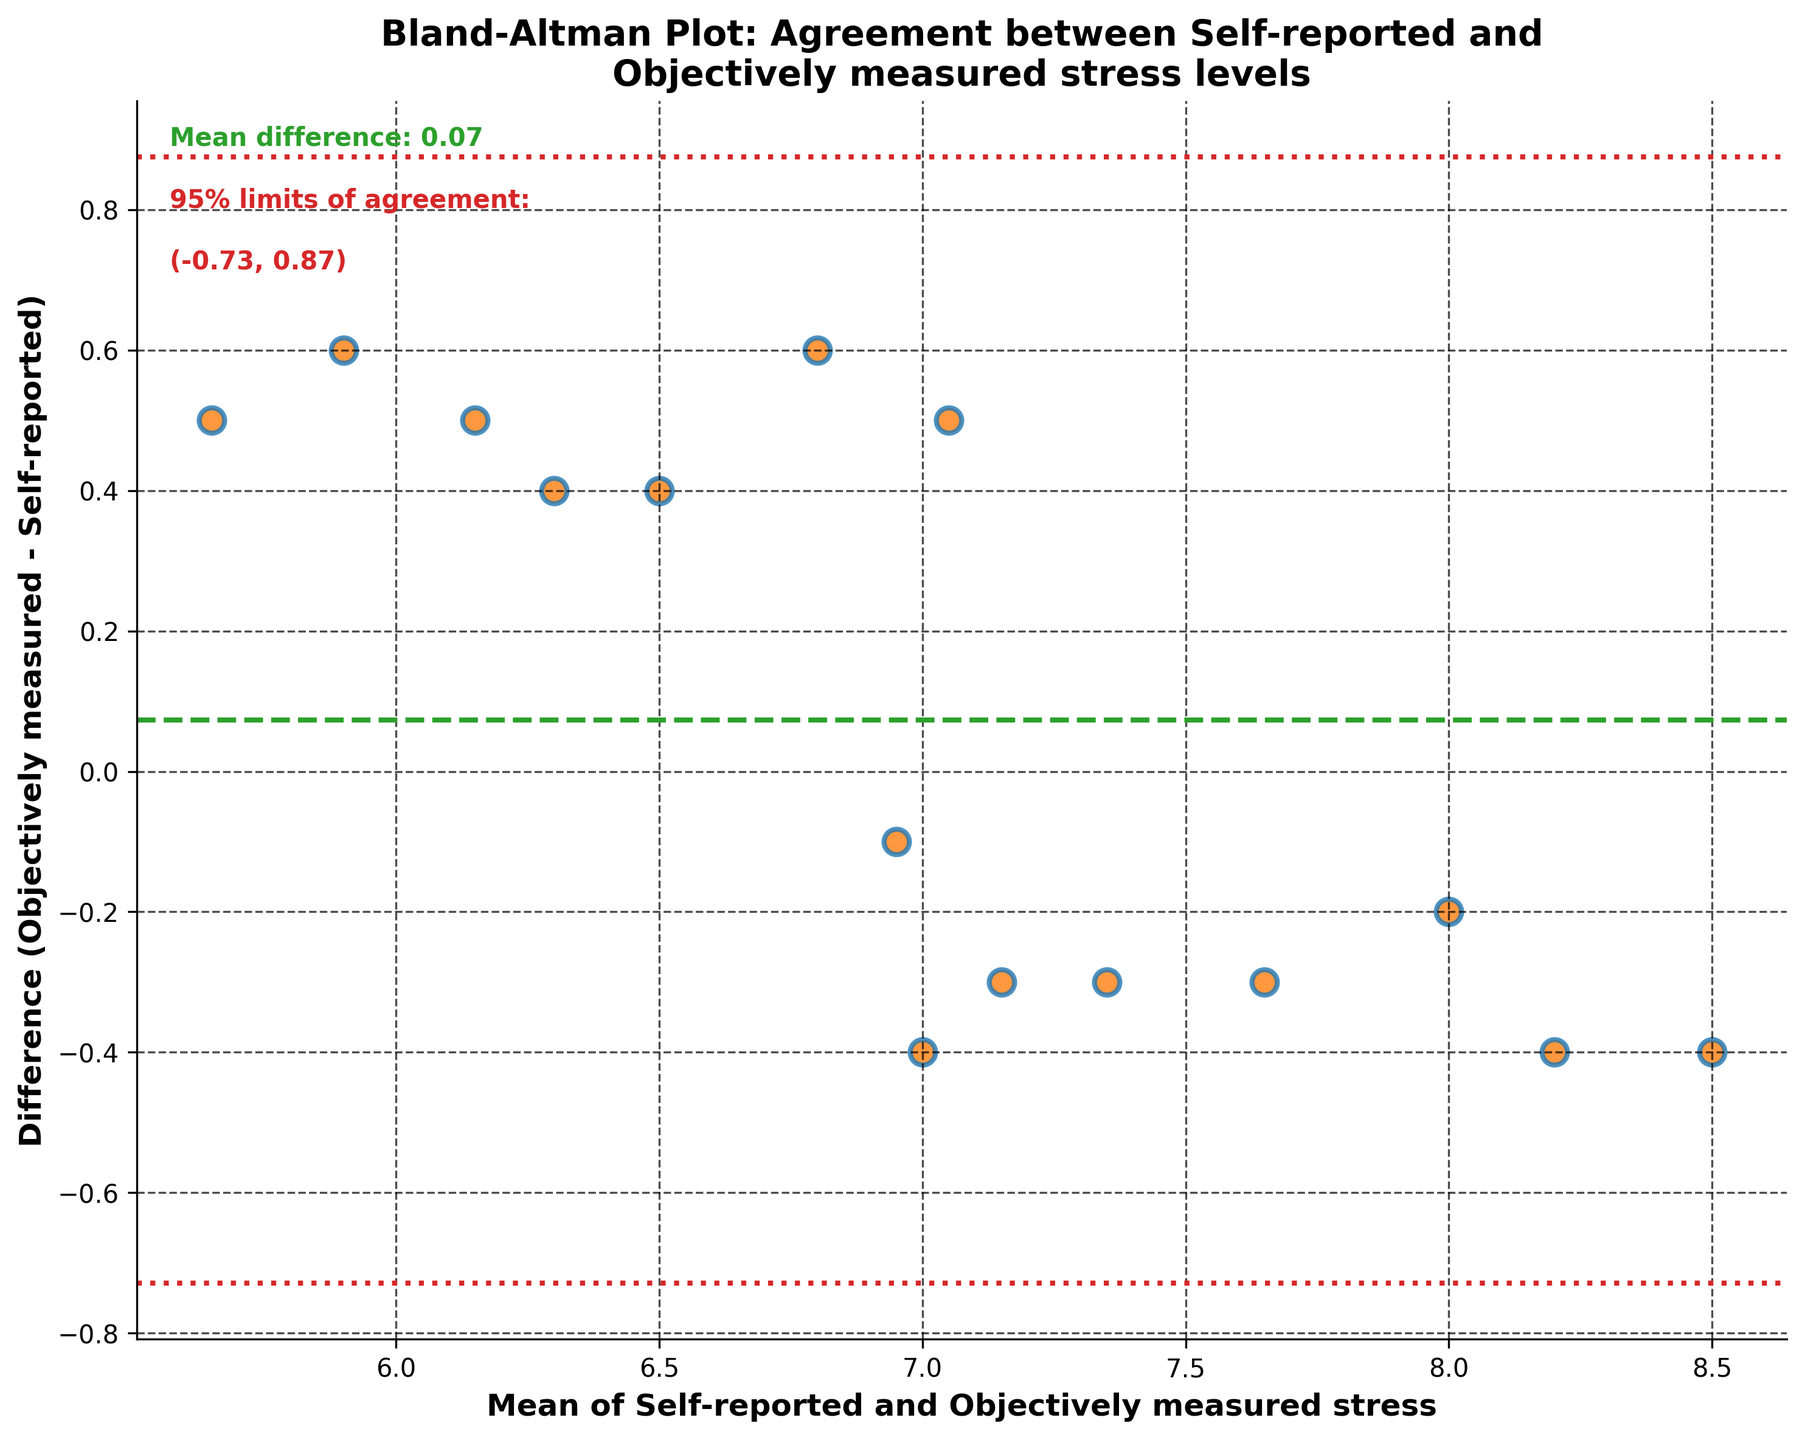What is the title of the plot? The title of the plot is prominently displayed at the top of the figure. It reads "Bland-Altman Plot: Agreement between Self-reported and Objectively measured stress levels."
Answer: Bland-Altman Plot: Agreement between Self-reported and Objectively measured stress levels How many data points are shown in the plot? Each scatter point represents a data point. By counting the points, one can determine there are 15 data points.
Answer: 15 What do the different lines on the plot represent? The plot features three horizontal lines: one dashed green line at the mean difference, and two dotted red lines representing the 95% limits of agreement. The mean difference is the average of the differences between objectively measured and self-reported stress, while the 95% limits of agreement represent the range within which most differences between the methods lie.
Answer: Mean difference and 95% limits of agreement What is the mean difference between self-reported and objectively measured stress levels? The plot has a label indicating the mean difference. It is calculated as the average of the differences (objectively measured stress minus self-reported stress), and the line at this value is also visually referenced. The mean difference is -0.18.
Answer: -0.18 What are the 95% limits of agreement? The 95% limits of agreement are shown with dotted red lines and are calculated as the mean difference plus and minus 1.96 times the standard deviation of the differences. The values of these limits are provided on the plot as (-0.67, 0.30).
Answer: (-0.67, 0.30) In what range do most of the differences between the two methods fall? Most differences fall within the 95% limits of agreement, which are between -0.67 and 0.30 as indicated by the dotted red lines on the plot.
Answer: Between -0.67 and 0.30 Which subject has the largest discrepancy between self-reported and objectively measured stress levels, and how much is it? By finding the scatter point that is farthest from the mean difference line, we see that it belongs to "Amy Rodriguez" with a difference of 0.5 (7.3 - 6.8).
Answer: Amy Rodriguez, 0.5 Is there a systematic bias between the self-reported and objectively measured stress levels? A systematic bias would be indicated by a consistent trend in the differences; the presence of the mean difference of -0.18 suggests a slight tendency for self-reported levels to be higher than the objectively measured levels.
Answer: Yes, slight bias Are there any data points outside the 95% limits of agreement? By observing the scatter plot, one can see that all data points fall within the dotted red lines, indicating no points lie outside the 95% limits of agreement.
Answer: No 